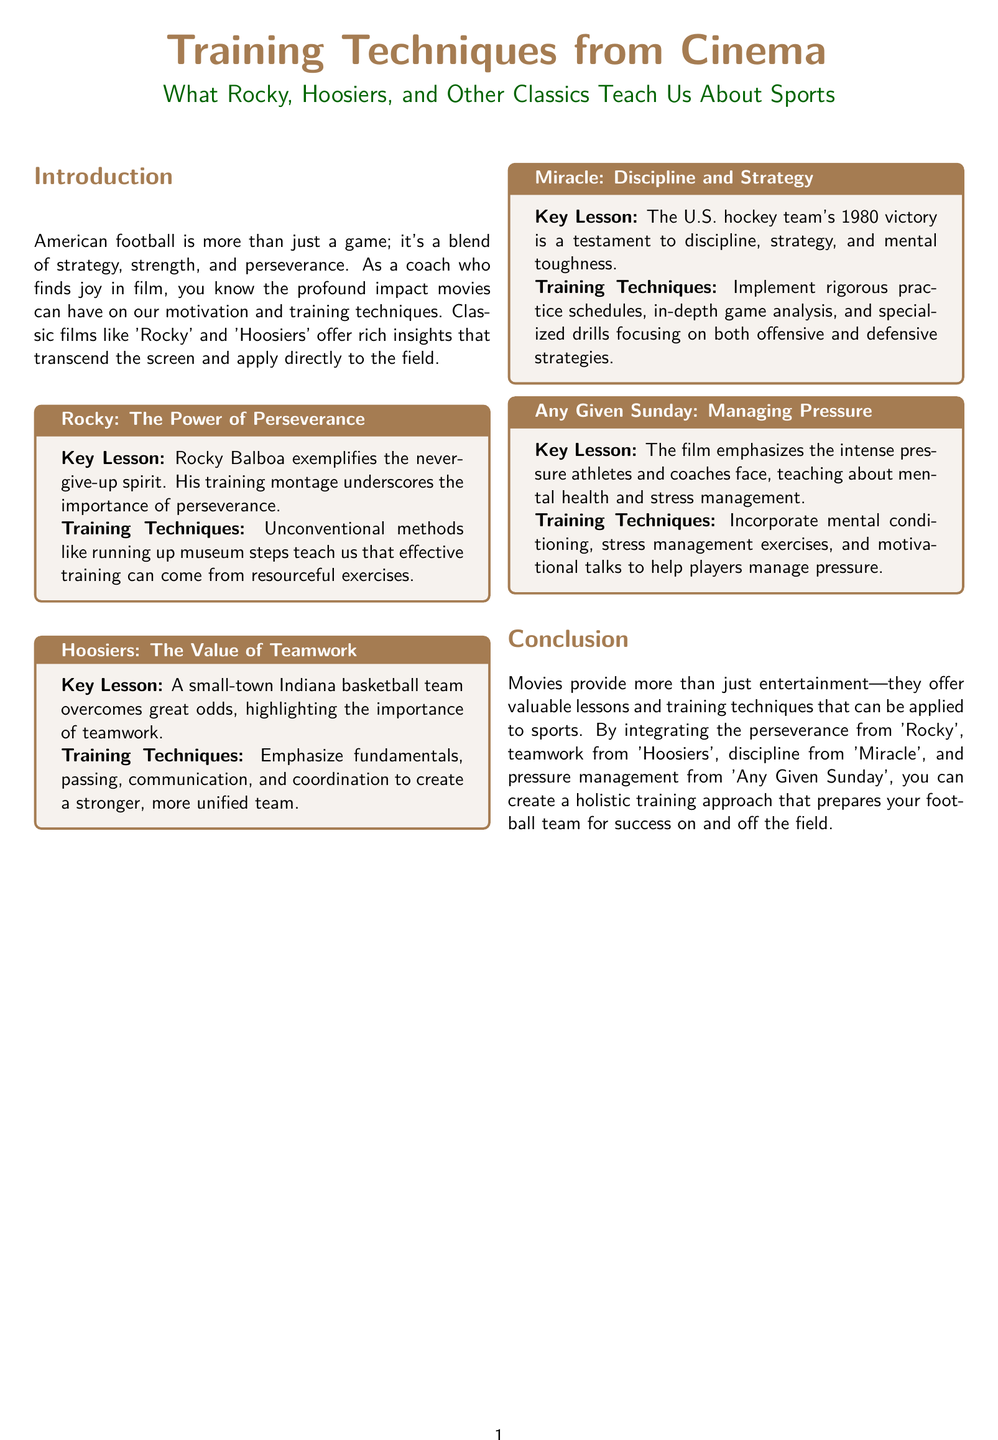What is the title of the document? The title of the document is stated in the introduction section as "Training Techniques from Cinema".
Answer: Training Techniques from Cinema Which movie exemplifies the never-give-up spirit? The document specifically highlights the character Rocky Balboa from the movie "Rocky" as an embodiment of perseverance.
Answer: Rocky What is a key training technique mentioned for 'Hoosiers'? The document emphasizes "fundamentals, passing, communication, and coordination" as key training techniques.
Answer: Fundamentals, passing, communication, and coordination What year did the U.S. hockey team achieve victory according to the document? The document refers to the U.S. hockey team's victory in 1980 as per the movie "Miracle".
Answer: 1980 What does 'Any Given Sunday' teach about athletes? According to the document, 'Any Given Sunday' teaches about "mental health and stress management" in the context of pressure athletes face.
Answer: Mental health and stress management What type of training technique is emphasized in 'Rocky'? The document mentions "unconventional methods" that can be derived from 'Rocky'.
Answer: Unconventional methods How many movies are discussed in the document? The document includes four movies: 'Rocky', 'Hoosiers', 'Miracle', and 'Any Given Sunday'.
Answer: Four What is the color of the section titles in the document? The section titles are specified to be in the color football brown.
Answer: Football brown What is the overall theme of the document? The document integrates training techniques from classic films and links them to sports coaching methods.
Answer: Training techniques from classic films 